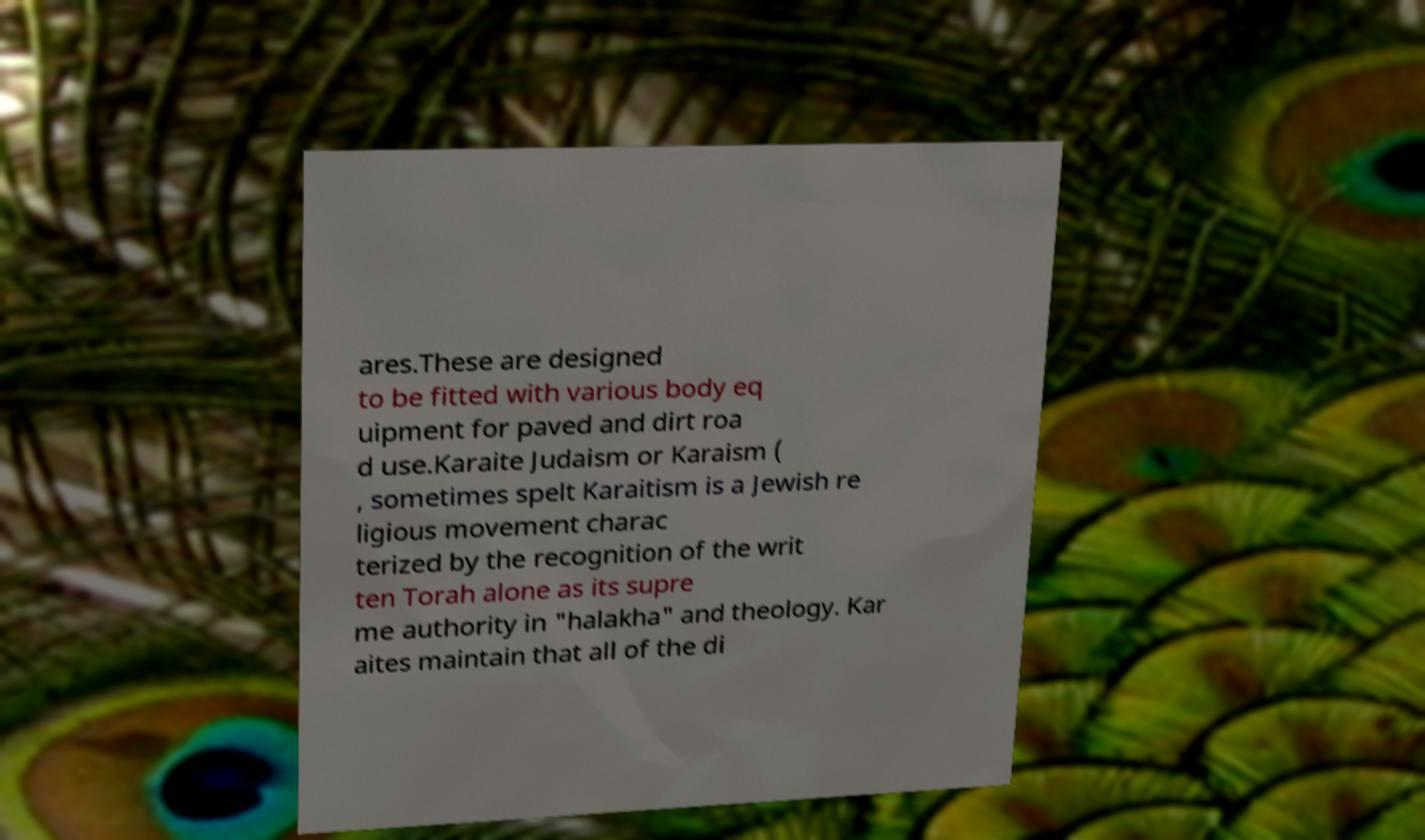For documentation purposes, I need the text within this image transcribed. Could you provide that? ares.These are designed to be fitted with various body eq uipment for paved and dirt roa d use.Karaite Judaism or Karaism ( , sometimes spelt Karaitism is a Jewish re ligious movement charac terized by the recognition of the writ ten Torah alone as its supre me authority in "halakha" and theology. Kar aites maintain that all of the di 